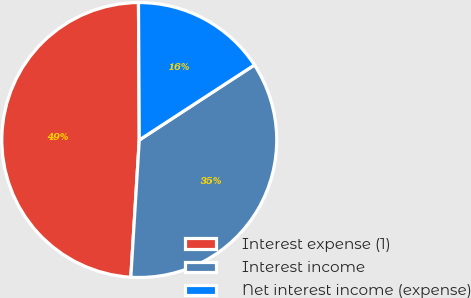Convert chart. <chart><loc_0><loc_0><loc_500><loc_500><pie_chart><fcel>Interest expense (1)<fcel>Interest income<fcel>Net interest income (expense)<nl><fcel>48.93%<fcel>35.17%<fcel>15.9%<nl></chart> 